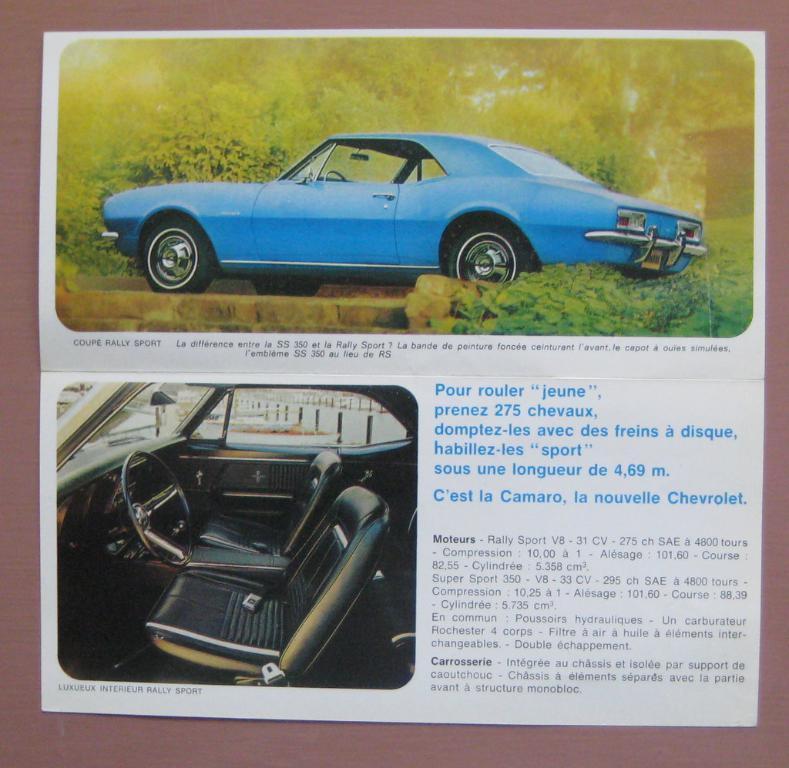Can you describe this image briefly? In this image, we can see an article contains two pictures and some text. In the first picture, we can see a car which is colored blue and in the second picture, we can see an inside view of a car. 